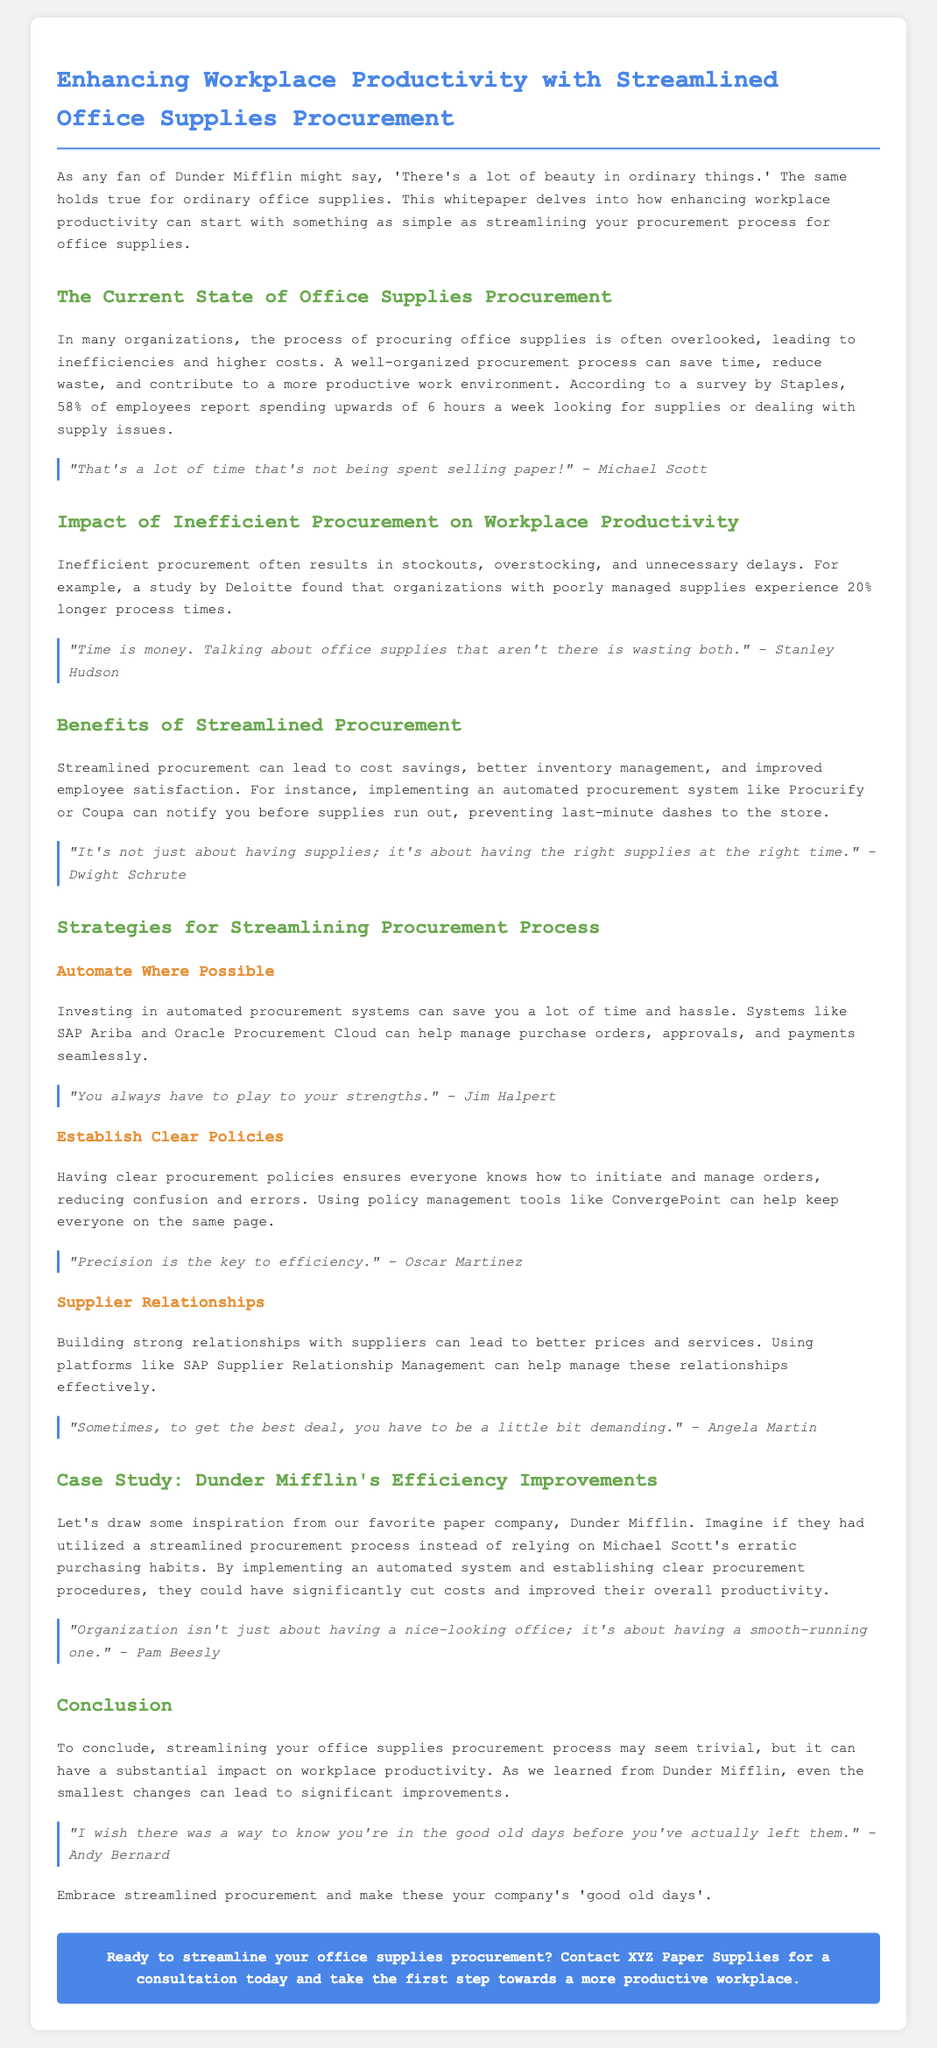What percentage of employees spend over six hours dealing with supply issues? The document states that according to a survey by Staples, 58% of employees report spending upwards of 6 hours a week looking for supplies or dealing with supply issues.
Answer: 58% What are two benefits of streamlined procurement mentioned? The document lists benefits such as cost savings and improved employee satisfaction resulting from streamlined procurement.
Answer: Cost savings, improved employee satisfaction What is one automated procurement system mentioned? The document mentions systems like Procurify and Coupa, which can notify you before supplies run out.
Answer: Procurify What does Stanley Hudson say about time and office supplies? Stanley Hudson comments that talking about office supplies that aren't there is wasting time and money.
Answer: Time is money Which company is used as a case study for efficiency improvements? The document provides Dunder Mifflin as a case study for efficiency improvements in office supplies procurement.
Answer: Dunder Mifflin What is one strategy suggested for streamlining the procurement process? One strategy suggested in the document is to establish clear policies regarding the procurement process.
Answer: Establish clear policies What is the main theme of the whitepaper? The main theme revolves around enhancing workplace productivity through a streamlined office supplies procurement process.
Answer: Enhancing workplace productivity Who is quoted as saying, "Precision is the key to efficiency"? Oscar Martinez is the one quoted in the document stating that precision is the key to efficiency.
Answer: Oscar Martinez 